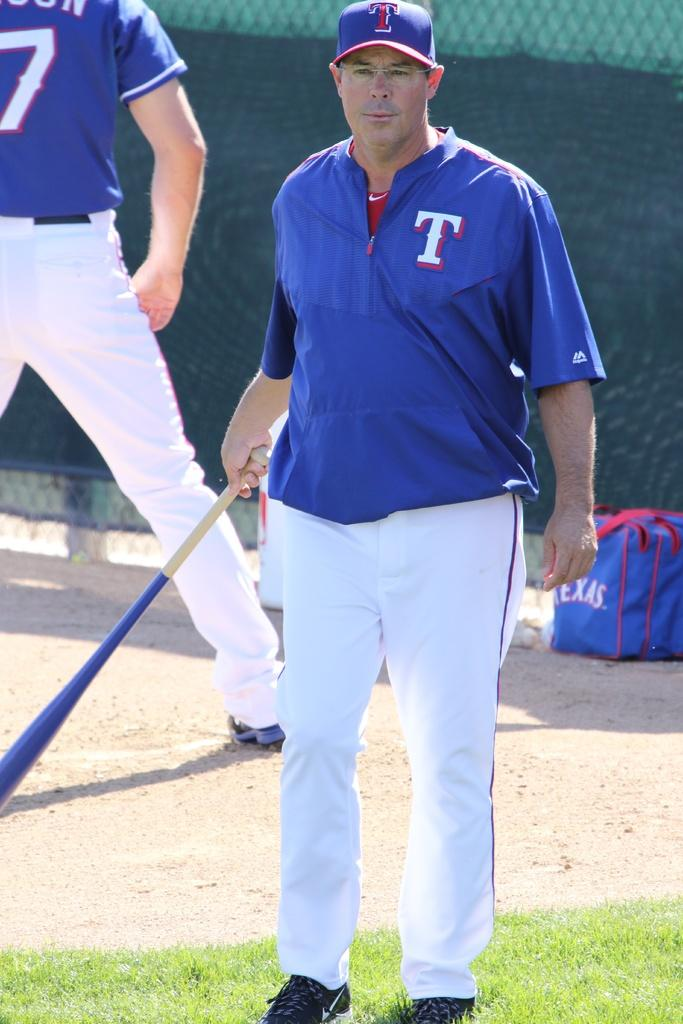<image>
Provide a brief description of the given image. A coach holding a bat standing in front of a bag labeled TEXAS. 